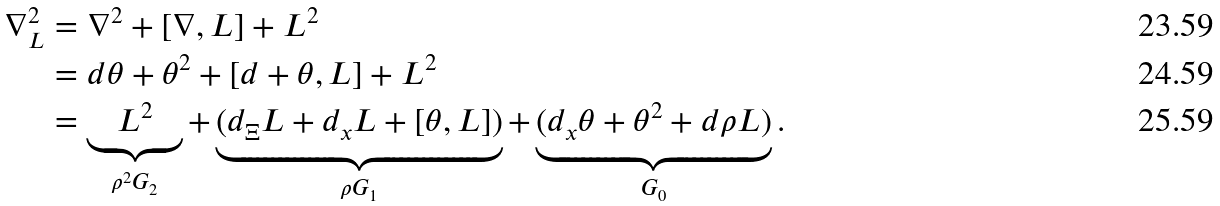<formula> <loc_0><loc_0><loc_500><loc_500>\nabla _ { L } ^ { 2 } & = \nabla ^ { 2 } + [ \nabla , L ] + L ^ { 2 } \\ & = d \theta + \theta ^ { 2 } + [ d + \theta , L ] + L ^ { 2 } \\ & = \underbrace { L ^ { 2 } } _ { \rho ^ { 2 } G _ { 2 } } + \underbrace { ( d _ { \Xi } L + d _ { x } L + [ \theta , L ] ) } _ { \rho G _ { 1 } } + \underbrace { ( d _ { x } \theta + \theta ^ { 2 } + d \rho L ) } _ { G _ { 0 } } .</formula> 